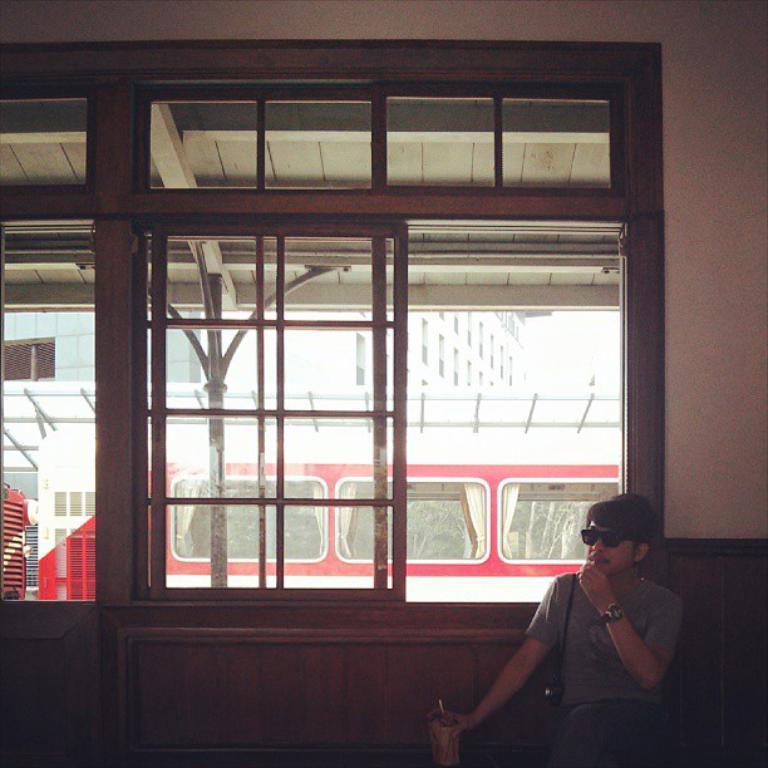Can you describe this image briefly? In this image we can see this person wearing a dress, glasses and wrist watch is holding a bottle in hands and sitting here. In the background, we can see the glass windows through which we can see a train and a building. 